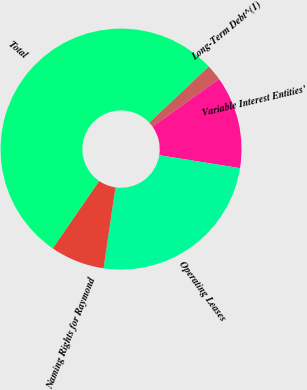<chart> <loc_0><loc_0><loc_500><loc_500><pie_chart><fcel>Long-Term Debt^(1)<fcel>Variable Interest Entities'<fcel>Operating Leases<fcel>Naming Rights for Raymond<fcel>Total<nl><fcel>2.16%<fcel>12.4%<fcel>24.79%<fcel>7.28%<fcel>53.37%<nl></chart> 